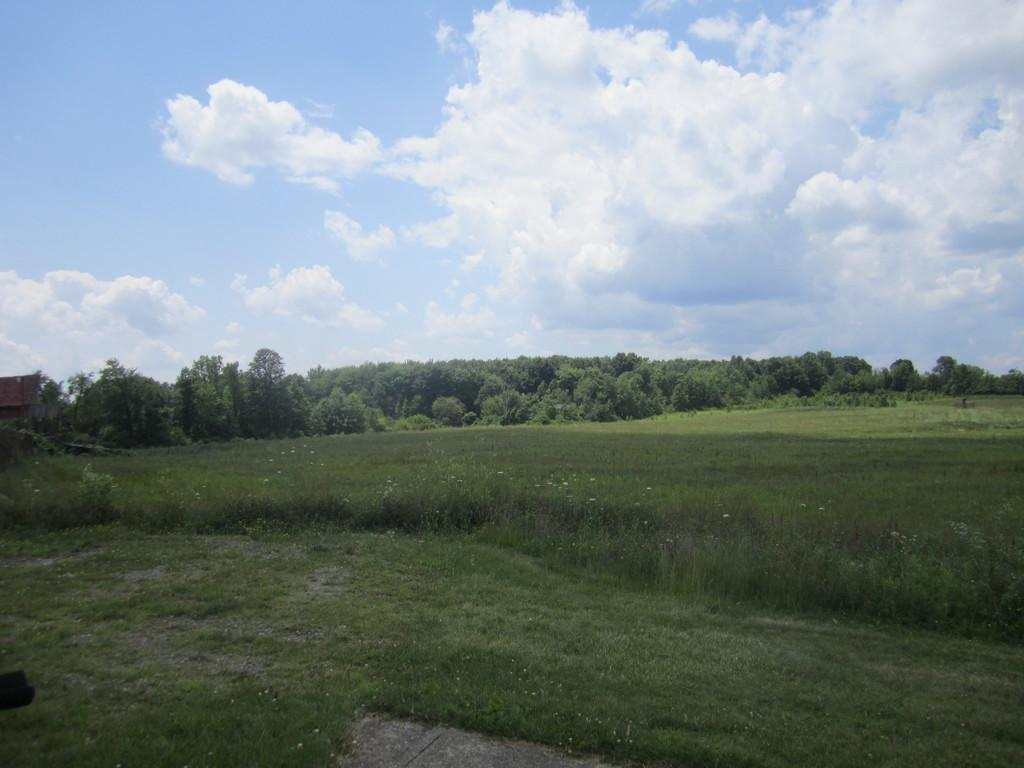What type of vegetation can be seen in the image? There is grass, plants, and trees visible in the image. What is visible in the sky in the image? There are clouds visible in the image. What type of birthday celebration is taking place in the image? There is no indication of a birthday celebration in the image; it features grass, plants, trees, and clouds. 